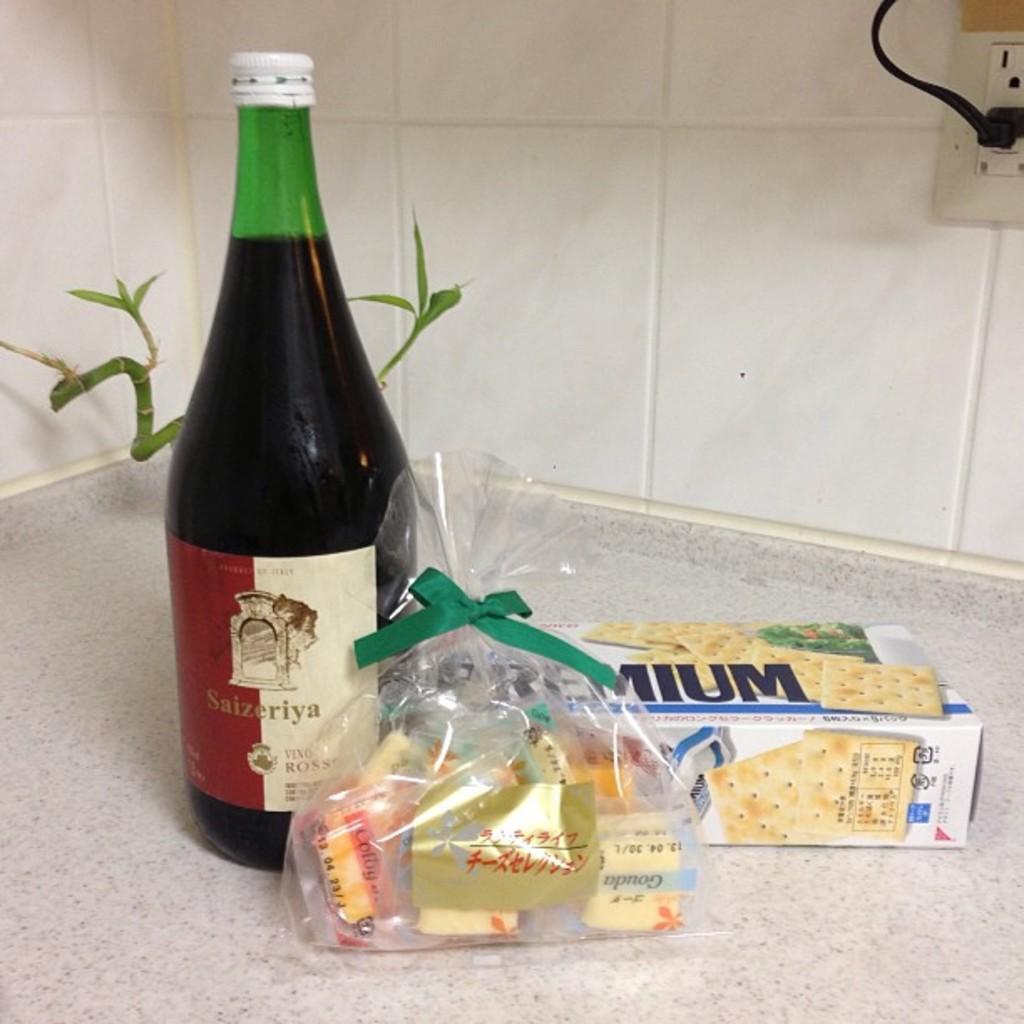What brand is the wine?
Offer a very short reply. Saizeriya. 